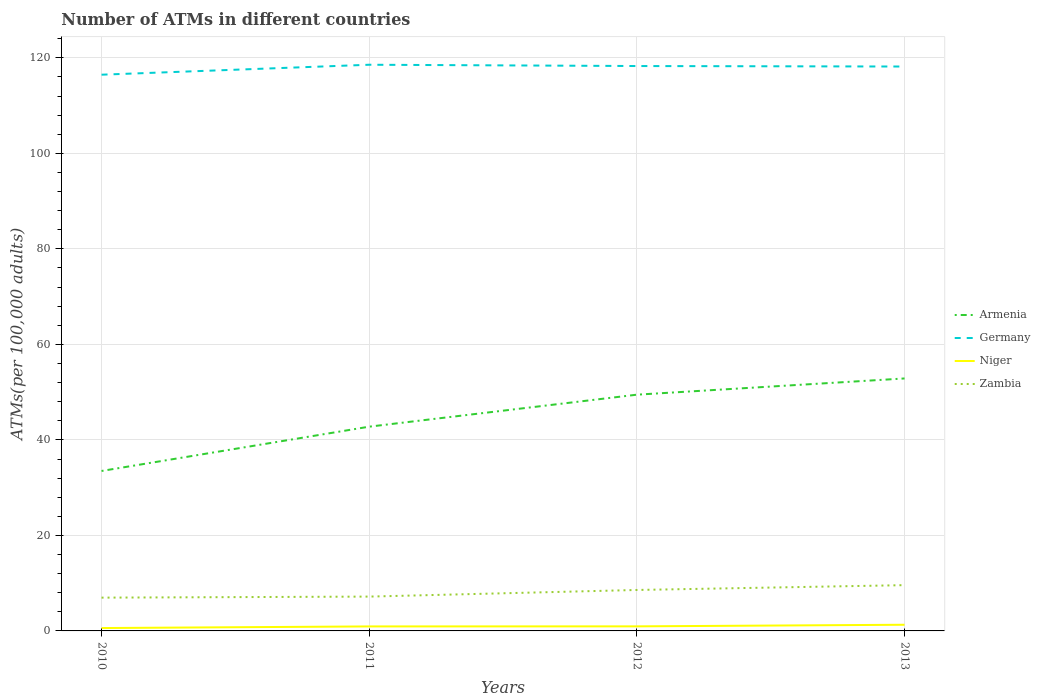How many different coloured lines are there?
Give a very brief answer. 4. Across all years, what is the maximum number of ATMs in Armenia?
Keep it short and to the point. 33.5. In which year was the number of ATMs in Niger maximum?
Provide a succinct answer. 2010. What is the total number of ATMs in Armenia in the graph?
Provide a short and direct response. -10.1. What is the difference between the highest and the second highest number of ATMs in Zambia?
Make the answer very short. 2.62. What is the difference between the highest and the lowest number of ATMs in Armenia?
Offer a very short reply. 2. How many lines are there?
Ensure brevity in your answer.  4. How many years are there in the graph?
Give a very brief answer. 4. What is the difference between two consecutive major ticks on the Y-axis?
Your response must be concise. 20. How are the legend labels stacked?
Ensure brevity in your answer.  Vertical. What is the title of the graph?
Ensure brevity in your answer.  Number of ATMs in different countries. What is the label or title of the Y-axis?
Your response must be concise. ATMs(per 100,0 adults). What is the ATMs(per 100,000 adults) in Armenia in 2010?
Make the answer very short. 33.5. What is the ATMs(per 100,000 adults) in Germany in 2010?
Keep it short and to the point. 116.48. What is the ATMs(per 100,000 adults) in Niger in 2010?
Keep it short and to the point. 0.6. What is the ATMs(per 100,000 adults) in Zambia in 2010?
Keep it short and to the point. 6.97. What is the ATMs(per 100,000 adults) in Armenia in 2011?
Your response must be concise. 42.77. What is the ATMs(per 100,000 adults) of Germany in 2011?
Provide a short and direct response. 118.56. What is the ATMs(per 100,000 adults) of Niger in 2011?
Offer a terse response. 0.94. What is the ATMs(per 100,000 adults) in Zambia in 2011?
Your answer should be compact. 7.19. What is the ATMs(per 100,000 adults) in Armenia in 2012?
Provide a succinct answer. 49.47. What is the ATMs(per 100,000 adults) of Germany in 2012?
Give a very brief answer. 118.29. What is the ATMs(per 100,000 adults) of Niger in 2012?
Your answer should be very brief. 0.96. What is the ATMs(per 100,000 adults) of Zambia in 2012?
Your response must be concise. 8.58. What is the ATMs(per 100,000 adults) of Armenia in 2013?
Your response must be concise. 52.87. What is the ATMs(per 100,000 adults) in Germany in 2013?
Give a very brief answer. 118.19. What is the ATMs(per 100,000 adults) of Niger in 2013?
Make the answer very short. 1.29. What is the ATMs(per 100,000 adults) in Zambia in 2013?
Offer a terse response. 9.59. Across all years, what is the maximum ATMs(per 100,000 adults) of Armenia?
Your answer should be very brief. 52.87. Across all years, what is the maximum ATMs(per 100,000 adults) of Germany?
Ensure brevity in your answer.  118.56. Across all years, what is the maximum ATMs(per 100,000 adults) of Niger?
Your answer should be compact. 1.29. Across all years, what is the maximum ATMs(per 100,000 adults) of Zambia?
Give a very brief answer. 9.59. Across all years, what is the minimum ATMs(per 100,000 adults) in Armenia?
Keep it short and to the point. 33.5. Across all years, what is the minimum ATMs(per 100,000 adults) in Germany?
Offer a terse response. 116.48. Across all years, what is the minimum ATMs(per 100,000 adults) of Niger?
Offer a terse response. 0.6. Across all years, what is the minimum ATMs(per 100,000 adults) of Zambia?
Ensure brevity in your answer.  6.97. What is the total ATMs(per 100,000 adults) in Armenia in the graph?
Ensure brevity in your answer.  178.61. What is the total ATMs(per 100,000 adults) of Germany in the graph?
Provide a short and direct response. 471.51. What is the total ATMs(per 100,000 adults) in Niger in the graph?
Offer a terse response. 3.79. What is the total ATMs(per 100,000 adults) of Zambia in the graph?
Offer a very short reply. 32.32. What is the difference between the ATMs(per 100,000 adults) of Armenia in 2010 and that in 2011?
Offer a very short reply. -9.28. What is the difference between the ATMs(per 100,000 adults) in Germany in 2010 and that in 2011?
Your answer should be compact. -2.08. What is the difference between the ATMs(per 100,000 adults) in Niger in 2010 and that in 2011?
Give a very brief answer. -0.34. What is the difference between the ATMs(per 100,000 adults) in Zambia in 2010 and that in 2011?
Make the answer very short. -0.22. What is the difference between the ATMs(per 100,000 adults) in Armenia in 2010 and that in 2012?
Ensure brevity in your answer.  -15.98. What is the difference between the ATMs(per 100,000 adults) of Germany in 2010 and that in 2012?
Offer a terse response. -1.81. What is the difference between the ATMs(per 100,000 adults) of Niger in 2010 and that in 2012?
Offer a terse response. -0.35. What is the difference between the ATMs(per 100,000 adults) in Zambia in 2010 and that in 2012?
Your response must be concise. -1.61. What is the difference between the ATMs(per 100,000 adults) in Armenia in 2010 and that in 2013?
Offer a terse response. -19.37. What is the difference between the ATMs(per 100,000 adults) of Germany in 2010 and that in 2013?
Give a very brief answer. -1.71. What is the difference between the ATMs(per 100,000 adults) of Niger in 2010 and that in 2013?
Provide a short and direct response. -0.69. What is the difference between the ATMs(per 100,000 adults) in Zambia in 2010 and that in 2013?
Provide a short and direct response. -2.62. What is the difference between the ATMs(per 100,000 adults) in Armenia in 2011 and that in 2012?
Your answer should be compact. -6.7. What is the difference between the ATMs(per 100,000 adults) in Germany in 2011 and that in 2012?
Offer a terse response. 0.27. What is the difference between the ATMs(per 100,000 adults) of Niger in 2011 and that in 2012?
Keep it short and to the point. -0.01. What is the difference between the ATMs(per 100,000 adults) of Zambia in 2011 and that in 2012?
Your response must be concise. -1.39. What is the difference between the ATMs(per 100,000 adults) of Armenia in 2011 and that in 2013?
Keep it short and to the point. -10.1. What is the difference between the ATMs(per 100,000 adults) of Germany in 2011 and that in 2013?
Offer a terse response. 0.37. What is the difference between the ATMs(per 100,000 adults) of Niger in 2011 and that in 2013?
Provide a succinct answer. -0.35. What is the difference between the ATMs(per 100,000 adults) of Zambia in 2011 and that in 2013?
Keep it short and to the point. -2.4. What is the difference between the ATMs(per 100,000 adults) of Armenia in 2012 and that in 2013?
Your answer should be compact. -3.4. What is the difference between the ATMs(per 100,000 adults) of Germany in 2012 and that in 2013?
Offer a terse response. 0.1. What is the difference between the ATMs(per 100,000 adults) of Niger in 2012 and that in 2013?
Ensure brevity in your answer.  -0.34. What is the difference between the ATMs(per 100,000 adults) in Zambia in 2012 and that in 2013?
Offer a terse response. -1.01. What is the difference between the ATMs(per 100,000 adults) of Armenia in 2010 and the ATMs(per 100,000 adults) of Germany in 2011?
Ensure brevity in your answer.  -85.07. What is the difference between the ATMs(per 100,000 adults) in Armenia in 2010 and the ATMs(per 100,000 adults) in Niger in 2011?
Give a very brief answer. 32.55. What is the difference between the ATMs(per 100,000 adults) in Armenia in 2010 and the ATMs(per 100,000 adults) in Zambia in 2011?
Make the answer very short. 26.31. What is the difference between the ATMs(per 100,000 adults) in Germany in 2010 and the ATMs(per 100,000 adults) in Niger in 2011?
Offer a terse response. 115.53. What is the difference between the ATMs(per 100,000 adults) in Germany in 2010 and the ATMs(per 100,000 adults) in Zambia in 2011?
Keep it short and to the point. 109.29. What is the difference between the ATMs(per 100,000 adults) of Niger in 2010 and the ATMs(per 100,000 adults) of Zambia in 2011?
Give a very brief answer. -6.59. What is the difference between the ATMs(per 100,000 adults) in Armenia in 2010 and the ATMs(per 100,000 adults) in Germany in 2012?
Ensure brevity in your answer.  -84.79. What is the difference between the ATMs(per 100,000 adults) in Armenia in 2010 and the ATMs(per 100,000 adults) in Niger in 2012?
Provide a short and direct response. 32.54. What is the difference between the ATMs(per 100,000 adults) in Armenia in 2010 and the ATMs(per 100,000 adults) in Zambia in 2012?
Provide a succinct answer. 24.92. What is the difference between the ATMs(per 100,000 adults) of Germany in 2010 and the ATMs(per 100,000 adults) of Niger in 2012?
Provide a short and direct response. 115.52. What is the difference between the ATMs(per 100,000 adults) in Germany in 2010 and the ATMs(per 100,000 adults) in Zambia in 2012?
Make the answer very short. 107.9. What is the difference between the ATMs(per 100,000 adults) of Niger in 2010 and the ATMs(per 100,000 adults) of Zambia in 2012?
Make the answer very short. -7.97. What is the difference between the ATMs(per 100,000 adults) of Armenia in 2010 and the ATMs(per 100,000 adults) of Germany in 2013?
Provide a succinct answer. -84.69. What is the difference between the ATMs(per 100,000 adults) of Armenia in 2010 and the ATMs(per 100,000 adults) of Niger in 2013?
Offer a terse response. 32.2. What is the difference between the ATMs(per 100,000 adults) in Armenia in 2010 and the ATMs(per 100,000 adults) in Zambia in 2013?
Your answer should be compact. 23.91. What is the difference between the ATMs(per 100,000 adults) in Germany in 2010 and the ATMs(per 100,000 adults) in Niger in 2013?
Your answer should be very brief. 115.18. What is the difference between the ATMs(per 100,000 adults) of Germany in 2010 and the ATMs(per 100,000 adults) of Zambia in 2013?
Offer a terse response. 106.89. What is the difference between the ATMs(per 100,000 adults) of Niger in 2010 and the ATMs(per 100,000 adults) of Zambia in 2013?
Your response must be concise. -8.98. What is the difference between the ATMs(per 100,000 adults) of Armenia in 2011 and the ATMs(per 100,000 adults) of Germany in 2012?
Keep it short and to the point. -75.52. What is the difference between the ATMs(per 100,000 adults) of Armenia in 2011 and the ATMs(per 100,000 adults) of Niger in 2012?
Your answer should be compact. 41.82. What is the difference between the ATMs(per 100,000 adults) in Armenia in 2011 and the ATMs(per 100,000 adults) in Zambia in 2012?
Make the answer very short. 34.2. What is the difference between the ATMs(per 100,000 adults) of Germany in 2011 and the ATMs(per 100,000 adults) of Niger in 2012?
Your response must be concise. 117.61. What is the difference between the ATMs(per 100,000 adults) of Germany in 2011 and the ATMs(per 100,000 adults) of Zambia in 2012?
Provide a short and direct response. 109.98. What is the difference between the ATMs(per 100,000 adults) of Niger in 2011 and the ATMs(per 100,000 adults) of Zambia in 2012?
Offer a very short reply. -7.63. What is the difference between the ATMs(per 100,000 adults) of Armenia in 2011 and the ATMs(per 100,000 adults) of Germany in 2013?
Keep it short and to the point. -75.42. What is the difference between the ATMs(per 100,000 adults) in Armenia in 2011 and the ATMs(per 100,000 adults) in Niger in 2013?
Provide a short and direct response. 41.48. What is the difference between the ATMs(per 100,000 adults) in Armenia in 2011 and the ATMs(per 100,000 adults) in Zambia in 2013?
Offer a terse response. 33.19. What is the difference between the ATMs(per 100,000 adults) in Germany in 2011 and the ATMs(per 100,000 adults) in Niger in 2013?
Your answer should be very brief. 117.27. What is the difference between the ATMs(per 100,000 adults) of Germany in 2011 and the ATMs(per 100,000 adults) of Zambia in 2013?
Your answer should be compact. 108.98. What is the difference between the ATMs(per 100,000 adults) of Niger in 2011 and the ATMs(per 100,000 adults) of Zambia in 2013?
Keep it short and to the point. -8.64. What is the difference between the ATMs(per 100,000 adults) in Armenia in 2012 and the ATMs(per 100,000 adults) in Germany in 2013?
Your answer should be compact. -68.72. What is the difference between the ATMs(per 100,000 adults) of Armenia in 2012 and the ATMs(per 100,000 adults) of Niger in 2013?
Make the answer very short. 48.18. What is the difference between the ATMs(per 100,000 adults) of Armenia in 2012 and the ATMs(per 100,000 adults) of Zambia in 2013?
Keep it short and to the point. 39.89. What is the difference between the ATMs(per 100,000 adults) in Germany in 2012 and the ATMs(per 100,000 adults) in Niger in 2013?
Keep it short and to the point. 117. What is the difference between the ATMs(per 100,000 adults) of Germany in 2012 and the ATMs(per 100,000 adults) of Zambia in 2013?
Keep it short and to the point. 108.7. What is the difference between the ATMs(per 100,000 adults) of Niger in 2012 and the ATMs(per 100,000 adults) of Zambia in 2013?
Ensure brevity in your answer.  -8.63. What is the average ATMs(per 100,000 adults) of Armenia per year?
Give a very brief answer. 44.65. What is the average ATMs(per 100,000 adults) in Germany per year?
Your answer should be very brief. 117.88. What is the average ATMs(per 100,000 adults) of Niger per year?
Give a very brief answer. 0.95. What is the average ATMs(per 100,000 adults) in Zambia per year?
Ensure brevity in your answer.  8.08. In the year 2010, what is the difference between the ATMs(per 100,000 adults) in Armenia and ATMs(per 100,000 adults) in Germany?
Offer a very short reply. -82.98. In the year 2010, what is the difference between the ATMs(per 100,000 adults) in Armenia and ATMs(per 100,000 adults) in Niger?
Your answer should be very brief. 32.89. In the year 2010, what is the difference between the ATMs(per 100,000 adults) of Armenia and ATMs(per 100,000 adults) of Zambia?
Your response must be concise. 26.53. In the year 2010, what is the difference between the ATMs(per 100,000 adults) of Germany and ATMs(per 100,000 adults) of Niger?
Ensure brevity in your answer.  115.87. In the year 2010, what is the difference between the ATMs(per 100,000 adults) in Germany and ATMs(per 100,000 adults) in Zambia?
Give a very brief answer. 109.51. In the year 2010, what is the difference between the ATMs(per 100,000 adults) of Niger and ATMs(per 100,000 adults) of Zambia?
Offer a very short reply. -6.37. In the year 2011, what is the difference between the ATMs(per 100,000 adults) of Armenia and ATMs(per 100,000 adults) of Germany?
Offer a terse response. -75.79. In the year 2011, what is the difference between the ATMs(per 100,000 adults) of Armenia and ATMs(per 100,000 adults) of Niger?
Your answer should be very brief. 41.83. In the year 2011, what is the difference between the ATMs(per 100,000 adults) in Armenia and ATMs(per 100,000 adults) in Zambia?
Give a very brief answer. 35.58. In the year 2011, what is the difference between the ATMs(per 100,000 adults) of Germany and ATMs(per 100,000 adults) of Niger?
Provide a short and direct response. 117.62. In the year 2011, what is the difference between the ATMs(per 100,000 adults) in Germany and ATMs(per 100,000 adults) in Zambia?
Your answer should be very brief. 111.37. In the year 2011, what is the difference between the ATMs(per 100,000 adults) of Niger and ATMs(per 100,000 adults) of Zambia?
Provide a short and direct response. -6.24. In the year 2012, what is the difference between the ATMs(per 100,000 adults) of Armenia and ATMs(per 100,000 adults) of Germany?
Keep it short and to the point. -68.82. In the year 2012, what is the difference between the ATMs(per 100,000 adults) of Armenia and ATMs(per 100,000 adults) of Niger?
Offer a very short reply. 48.52. In the year 2012, what is the difference between the ATMs(per 100,000 adults) in Armenia and ATMs(per 100,000 adults) in Zambia?
Ensure brevity in your answer.  40.9. In the year 2012, what is the difference between the ATMs(per 100,000 adults) in Germany and ATMs(per 100,000 adults) in Niger?
Make the answer very short. 117.33. In the year 2012, what is the difference between the ATMs(per 100,000 adults) of Germany and ATMs(per 100,000 adults) of Zambia?
Provide a short and direct response. 109.71. In the year 2012, what is the difference between the ATMs(per 100,000 adults) in Niger and ATMs(per 100,000 adults) in Zambia?
Your answer should be compact. -7.62. In the year 2013, what is the difference between the ATMs(per 100,000 adults) in Armenia and ATMs(per 100,000 adults) in Germany?
Your answer should be very brief. -65.32. In the year 2013, what is the difference between the ATMs(per 100,000 adults) of Armenia and ATMs(per 100,000 adults) of Niger?
Make the answer very short. 51.58. In the year 2013, what is the difference between the ATMs(per 100,000 adults) in Armenia and ATMs(per 100,000 adults) in Zambia?
Give a very brief answer. 43.28. In the year 2013, what is the difference between the ATMs(per 100,000 adults) in Germany and ATMs(per 100,000 adults) in Niger?
Offer a very short reply. 116.89. In the year 2013, what is the difference between the ATMs(per 100,000 adults) in Germany and ATMs(per 100,000 adults) in Zambia?
Ensure brevity in your answer.  108.6. In the year 2013, what is the difference between the ATMs(per 100,000 adults) of Niger and ATMs(per 100,000 adults) of Zambia?
Provide a succinct answer. -8.29. What is the ratio of the ATMs(per 100,000 adults) of Armenia in 2010 to that in 2011?
Provide a succinct answer. 0.78. What is the ratio of the ATMs(per 100,000 adults) in Germany in 2010 to that in 2011?
Give a very brief answer. 0.98. What is the ratio of the ATMs(per 100,000 adults) of Niger in 2010 to that in 2011?
Give a very brief answer. 0.64. What is the ratio of the ATMs(per 100,000 adults) of Zambia in 2010 to that in 2011?
Your response must be concise. 0.97. What is the ratio of the ATMs(per 100,000 adults) of Armenia in 2010 to that in 2012?
Provide a succinct answer. 0.68. What is the ratio of the ATMs(per 100,000 adults) of Germany in 2010 to that in 2012?
Keep it short and to the point. 0.98. What is the ratio of the ATMs(per 100,000 adults) of Niger in 2010 to that in 2012?
Your answer should be compact. 0.63. What is the ratio of the ATMs(per 100,000 adults) of Zambia in 2010 to that in 2012?
Ensure brevity in your answer.  0.81. What is the ratio of the ATMs(per 100,000 adults) of Armenia in 2010 to that in 2013?
Keep it short and to the point. 0.63. What is the ratio of the ATMs(per 100,000 adults) of Germany in 2010 to that in 2013?
Your response must be concise. 0.99. What is the ratio of the ATMs(per 100,000 adults) of Niger in 2010 to that in 2013?
Ensure brevity in your answer.  0.47. What is the ratio of the ATMs(per 100,000 adults) of Zambia in 2010 to that in 2013?
Provide a short and direct response. 0.73. What is the ratio of the ATMs(per 100,000 adults) in Armenia in 2011 to that in 2012?
Make the answer very short. 0.86. What is the ratio of the ATMs(per 100,000 adults) in Niger in 2011 to that in 2012?
Offer a very short reply. 0.99. What is the ratio of the ATMs(per 100,000 adults) in Zambia in 2011 to that in 2012?
Offer a very short reply. 0.84. What is the ratio of the ATMs(per 100,000 adults) of Armenia in 2011 to that in 2013?
Provide a succinct answer. 0.81. What is the ratio of the ATMs(per 100,000 adults) of Niger in 2011 to that in 2013?
Ensure brevity in your answer.  0.73. What is the ratio of the ATMs(per 100,000 adults) of Zambia in 2011 to that in 2013?
Offer a very short reply. 0.75. What is the ratio of the ATMs(per 100,000 adults) of Armenia in 2012 to that in 2013?
Offer a very short reply. 0.94. What is the ratio of the ATMs(per 100,000 adults) of Niger in 2012 to that in 2013?
Ensure brevity in your answer.  0.74. What is the ratio of the ATMs(per 100,000 adults) in Zambia in 2012 to that in 2013?
Provide a short and direct response. 0.89. What is the difference between the highest and the second highest ATMs(per 100,000 adults) in Armenia?
Your response must be concise. 3.4. What is the difference between the highest and the second highest ATMs(per 100,000 adults) in Germany?
Give a very brief answer. 0.27. What is the difference between the highest and the second highest ATMs(per 100,000 adults) of Niger?
Keep it short and to the point. 0.34. What is the difference between the highest and the second highest ATMs(per 100,000 adults) in Zambia?
Offer a terse response. 1.01. What is the difference between the highest and the lowest ATMs(per 100,000 adults) of Armenia?
Keep it short and to the point. 19.37. What is the difference between the highest and the lowest ATMs(per 100,000 adults) of Germany?
Give a very brief answer. 2.08. What is the difference between the highest and the lowest ATMs(per 100,000 adults) in Niger?
Your answer should be compact. 0.69. What is the difference between the highest and the lowest ATMs(per 100,000 adults) in Zambia?
Give a very brief answer. 2.62. 